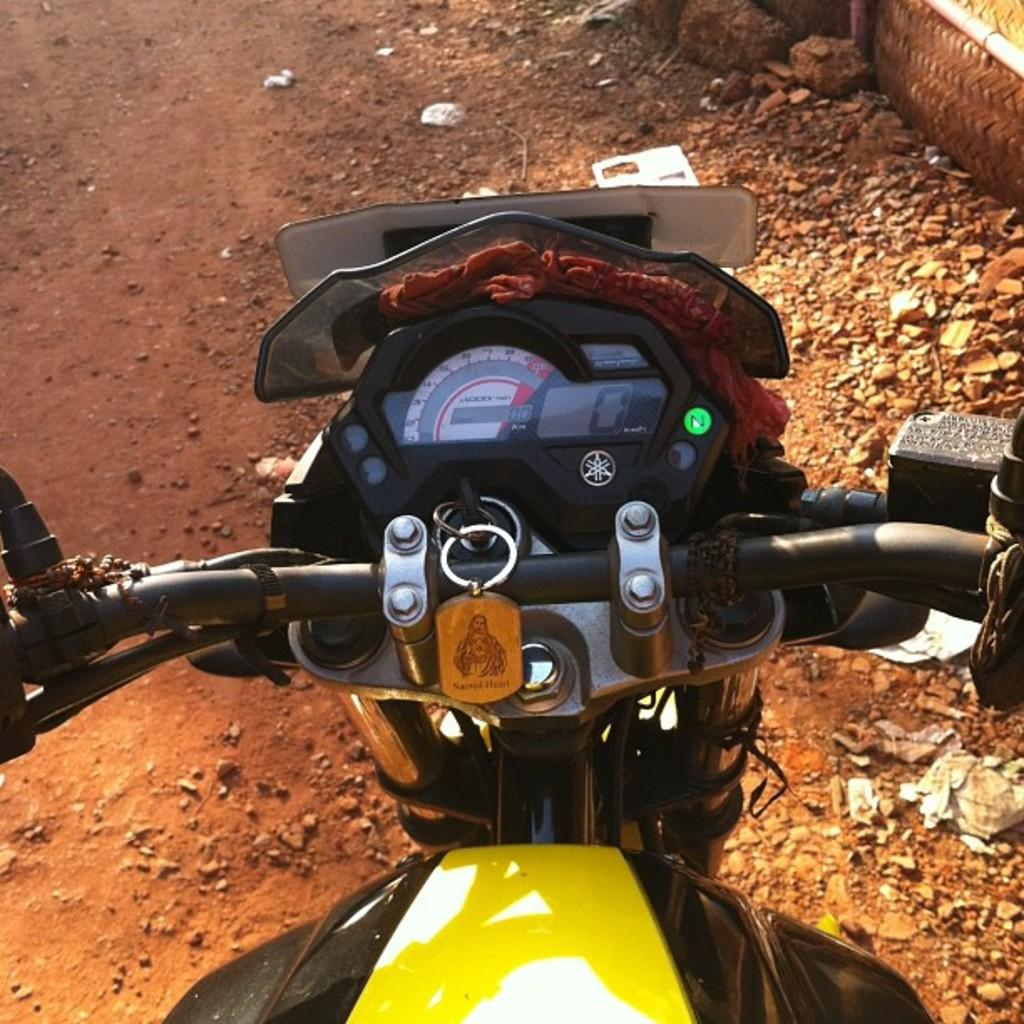What is the main subject of the image? The main subject of the image is a bike. What colors can be seen on the bike? The bike is yellow and black in color. Where is the bike located in the image? The bike is on the road. Can you hear the record playing in the background of the image? There is no record present in the image, so it cannot be heard playing in the background. 